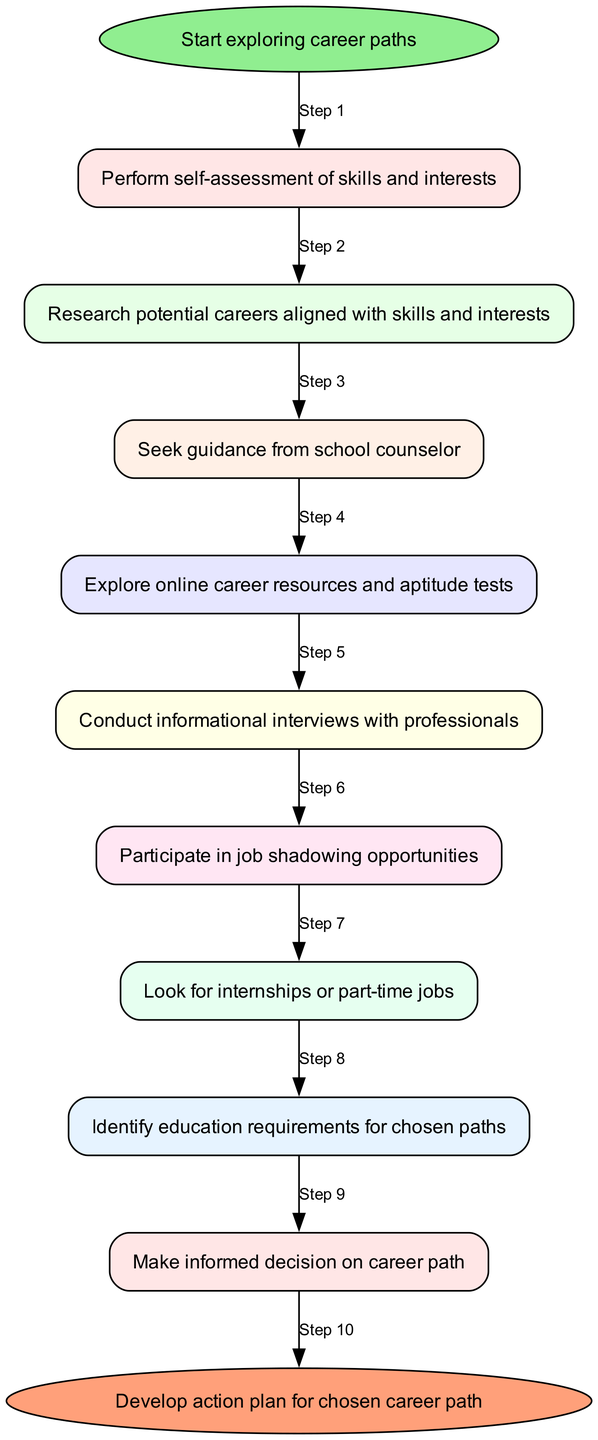What is the initial step in the workflow? The diagram indicates that the first step in the workflow is labeled "Start exploring career paths." This is the entry point of the process.
Answer: Start exploring career paths How many total steps are there in the workflow? By counting the steps represented in the diagram, we find there are ten labeled steps from "Start exploring career paths" to "Develop action plan for chosen career path."
Answer: Ten Which node follows the "Research potential careers aligned with skills and interests" node? The flow indicates that after the "Research potential careers aligned with skills and interests," the next step is "Seek guidance from school counselor."
Answer: Seek guidance from school counselor What color is the end node? In the diagram, the end node is represented in a light coral color (#FFA07A). This color distinguishes the end step from others.
Answer: Light coral What is the relationship between "Participate in job shadowing opportunities" and "Look for internships or part-time jobs"? "Participate in job shadowing opportunities" is a prerequisite for "Look for internships or part-time jobs," as indicated by the direct edge connecting these two nodes.
Answer: Prerequisite What step comes before "Make informed decision on career path"? The step immediately preceding "Make informed decision on career path" is to "Identify education requirements for chosen paths." This indicates a sequence in the decision-making process.
Answer: Identify education requirements for chosen paths How does one move from "Conduct informational interviews with professionals" to the next step? The transition from "Conduct informational interviews with professionals" to "Participate in job shadowing opportunities" is shown by an edge that connects these two nodes, indicating a flow of steps.
Answer: Through an edge connection What main action is suggested after seeking guidance from a school counselor? After seeking guidance from a school counselor, the workflow suggests exploring online career resources and aptitude tests as the next course of action.
Answer: Explore online career resources and aptitude tests Which node represents a step that provides real-world experience? The node "Look for internships or part-time jobs" represents a step that is intended to provide real-world experience, as it encourages practical engagement in a career field.
Answer: Look for internships or part-time jobs 